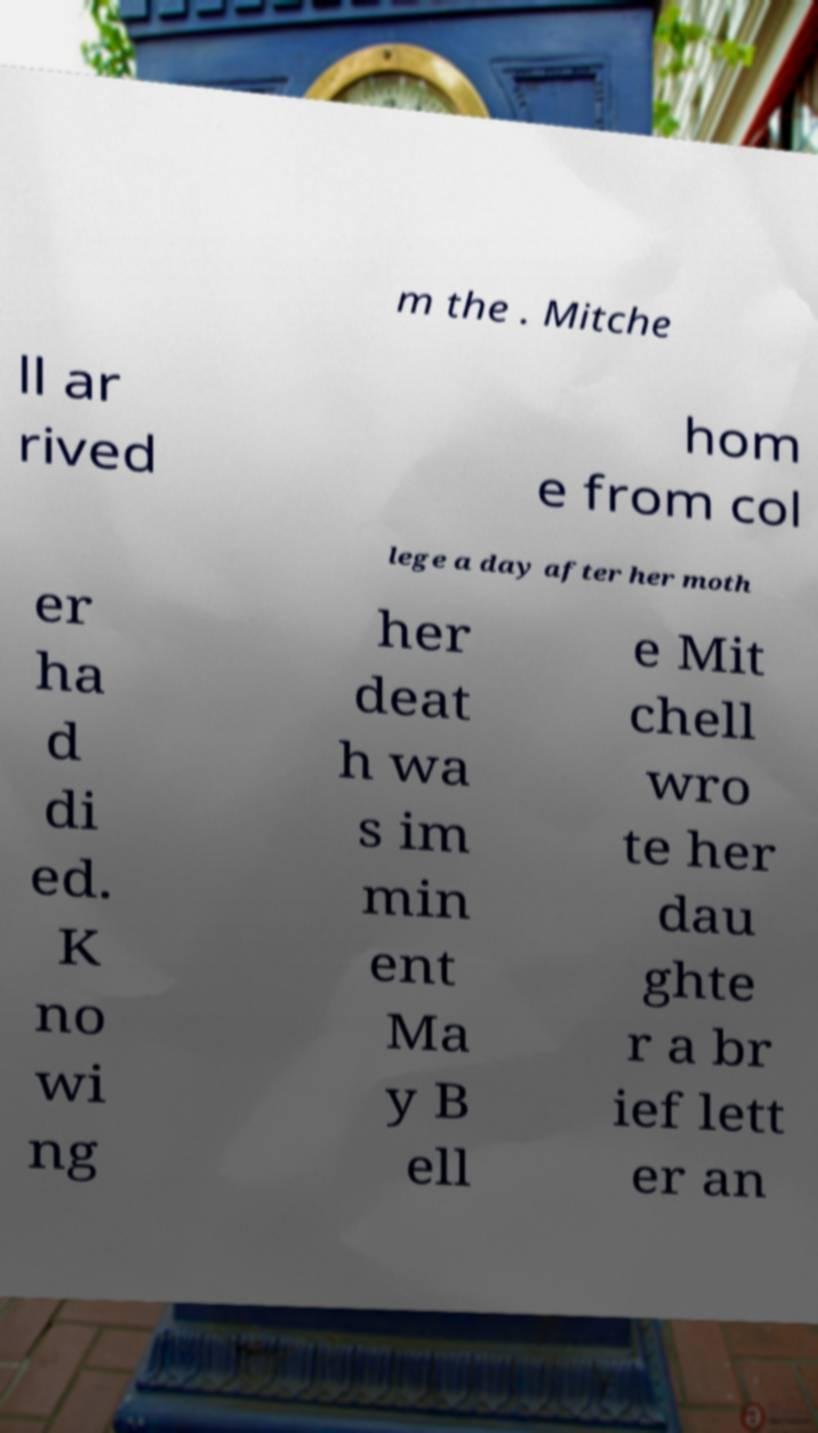There's text embedded in this image that I need extracted. Can you transcribe it verbatim? m the . Mitche ll ar rived hom e from col lege a day after her moth er ha d di ed. K no wi ng her deat h wa s im min ent Ma y B ell e Mit chell wro te her dau ghte r a br ief lett er an 